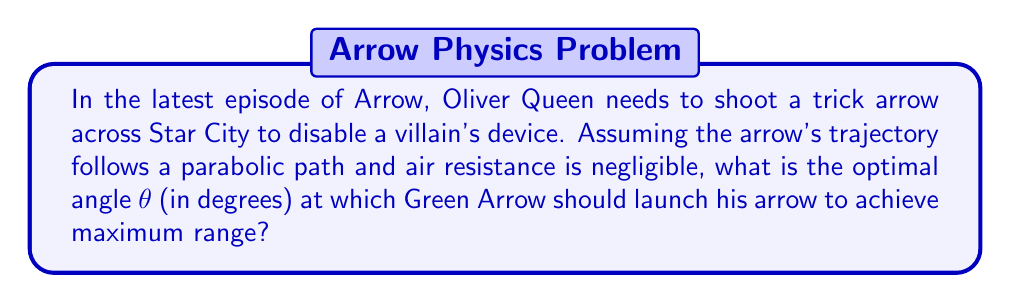Help me with this question. Let's approach this step-by-step using the principles of projectile motion:

1. The range R of a projectile launched at an angle θ with initial velocity v₀ is given by:

   $$R = \frac{v_0^2 \sin(2θ)}{g}$$

   where g is the acceleration due to gravity (9.8 m/s²).

2. To find the maximum range, we need to maximize sin(2θ). 

3. The sine function reaches its maximum value of 1 when its argument is 90°.

4. Therefore, we want:

   $$2θ = 90°$$

5. Solving for θ:

   $$θ = 45°$$

6. We can verify this result by considering the symmetry of the parabolic trajectory. At 45°, the time spent going up equals the time spent coming down, which intuitively maximizes the range.

[asy]
import graph;
size(200,150);

real f(real x) {return -x^2+x;}
draw(graph(f,0,1),red);

draw((0,0)--(1,0),arrow=Arrow);
draw((0,0)--(0,0.3),arrow=Arrow);

label("x",1.1,0);
label("y",0,0.35);

draw((0,0)--(0.7,0.7),blue,arrow=Arrow);
draw(arc((0,0),0.2,0,45),black);

label("$45°$",(0.15,0.1),NE);
label("v₀",0.4,0.5,NW);
[/asy]

This diagram illustrates the optimal 45° launch angle for maximum range.
Answer: 45° 